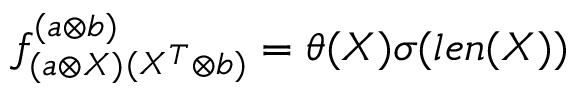<formula> <loc_0><loc_0><loc_500><loc_500>f _ { ( a \otimes X ) } ^ { ( a \otimes b ) _ { ( X ^ { T } \otimes b ) } = \theta ( X ) \sigma ( l e n ( X ) )</formula> 